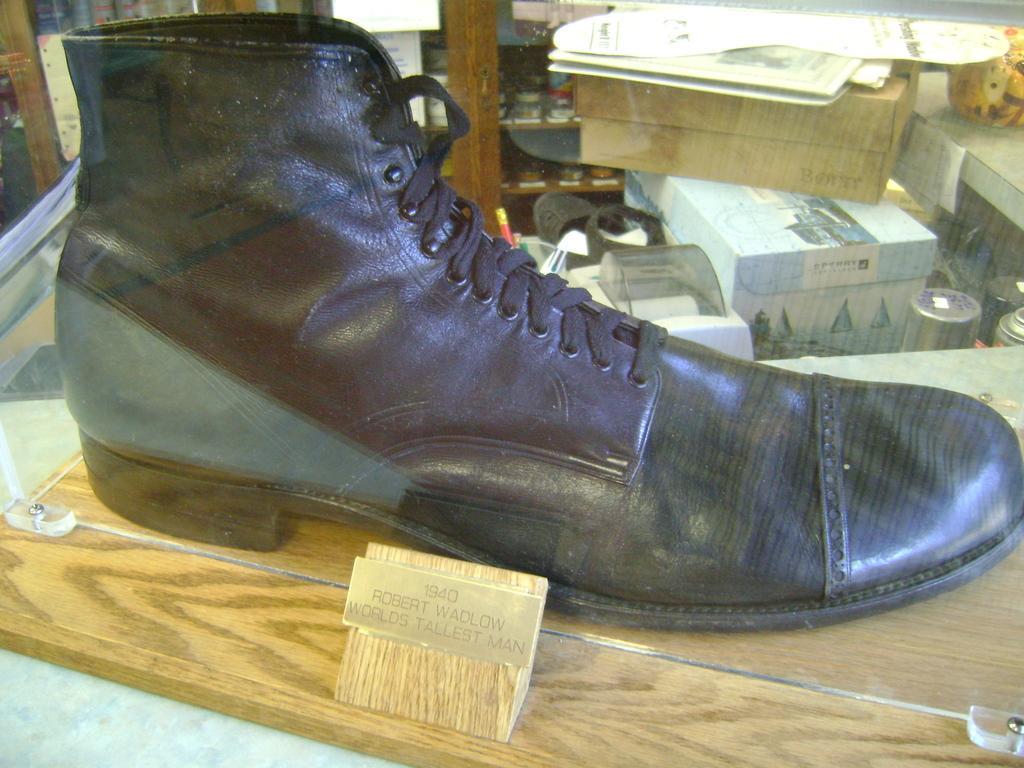Please provide a concise description of this image. In this picture we can see text and a shoe on the wooden surface. In the background we can see boxes, papers and some objects. 